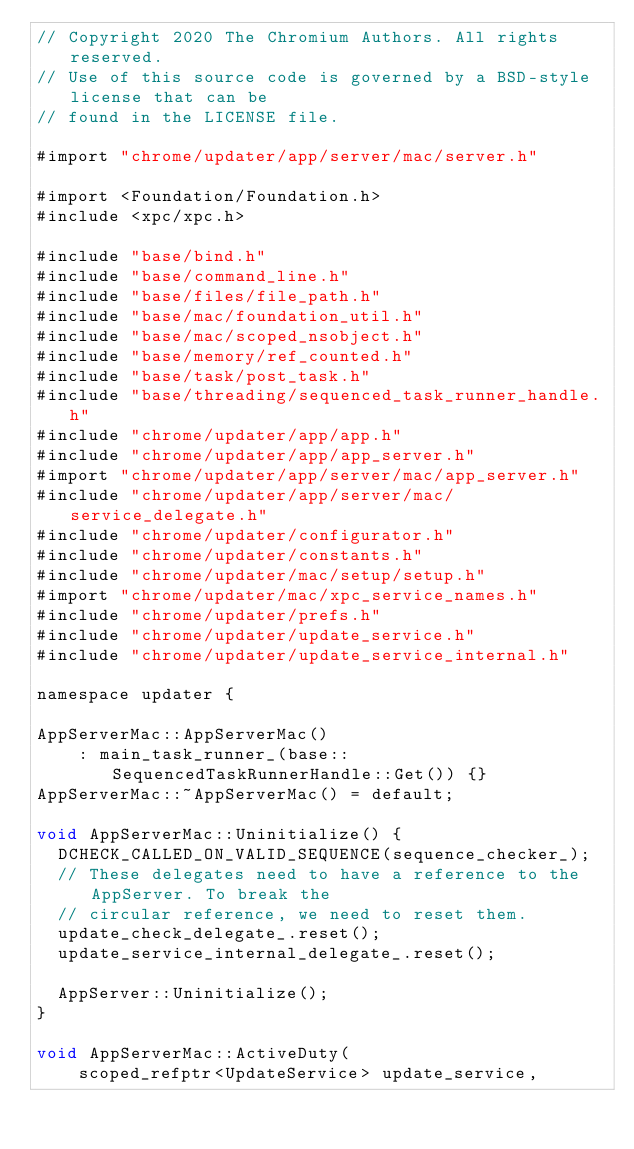Convert code to text. <code><loc_0><loc_0><loc_500><loc_500><_ObjectiveC_>// Copyright 2020 The Chromium Authors. All rights reserved.
// Use of this source code is governed by a BSD-style license that can be
// found in the LICENSE file.

#import "chrome/updater/app/server/mac/server.h"

#import <Foundation/Foundation.h>
#include <xpc/xpc.h>

#include "base/bind.h"
#include "base/command_line.h"
#include "base/files/file_path.h"
#include "base/mac/foundation_util.h"
#include "base/mac/scoped_nsobject.h"
#include "base/memory/ref_counted.h"
#include "base/task/post_task.h"
#include "base/threading/sequenced_task_runner_handle.h"
#include "chrome/updater/app/app.h"
#include "chrome/updater/app/app_server.h"
#import "chrome/updater/app/server/mac/app_server.h"
#include "chrome/updater/app/server/mac/service_delegate.h"
#include "chrome/updater/configurator.h"
#include "chrome/updater/constants.h"
#include "chrome/updater/mac/setup/setup.h"
#import "chrome/updater/mac/xpc_service_names.h"
#include "chrome/updater/prefs.h"
#include "chrome/updater/update_service.h"
#include "chrome/updater/update_service_internal.h"

namespace updater {

AppServerMac::AppServerMac()
    : main_task_runner_(base::SequencedTaskRunnerHandle::Get()) {}
AppServerMac::~AppServerMac() = default;

void AppServerMac::Uninitialize() {
  DCHECK_CALLED_ON_VALID_SEQUENCE(sequence_checker_);
  // These delegates need to have a reference to the AppServer. To break the
  // circular reference, we need to reset them.
  update_check_delegate_.reset();
  update_service_internal_delegate_.reset();

  AppServer::Uninitialize();
}

void AppServerMac::ActiveDuty(
    scoped_refptr<UpdateService> update_service,</code> 